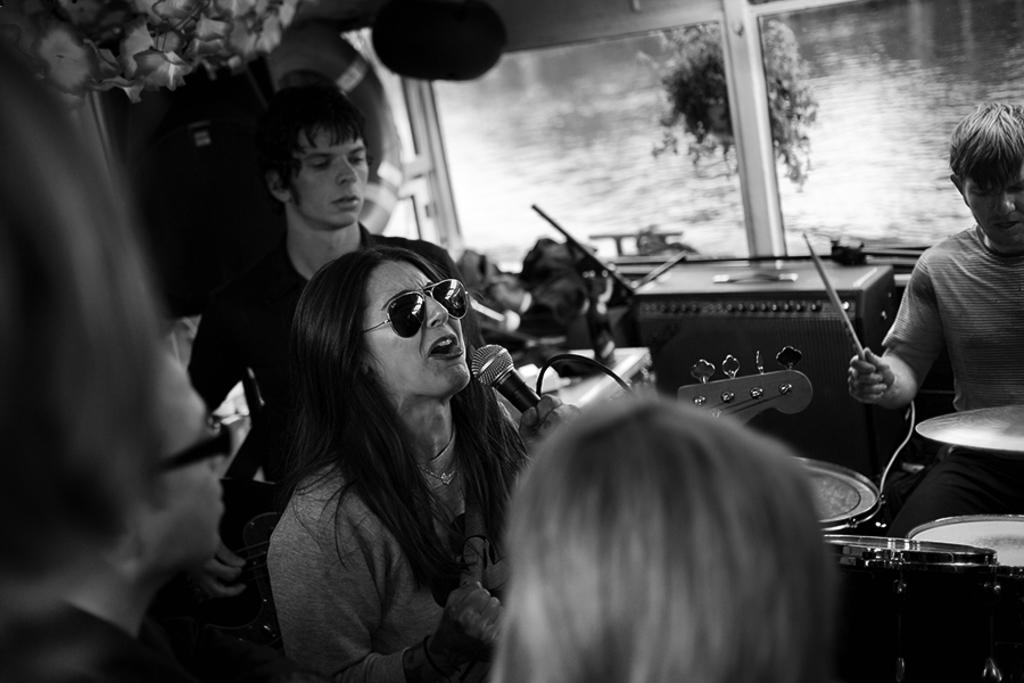Who is the main subject in the image? There is a lady in the image. What is the lady holding in her hand? The lady is holding a microphone in her hand. What is the lady doing in the image? The lady is playing a guitar. Can you describe the background of the image? There are people in the background of the image, and they are playing musical instruments. There is also a glass window in the background. What type of sweater is the lady wearing in the image? The provided facts do not mention any clothing, including a sweater, so we cannot determine the type of sweater the lady is wearing in the image. 